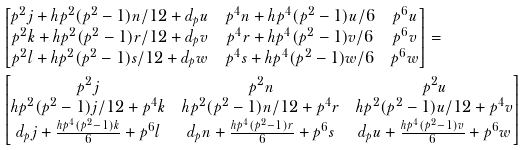Convert formula to latex. <formula><loc_0><loc_0><loc_500><loc_500>& \begin{bmatrix} p ^ { 2 } j + h p ^ { 2 } ( p ^ { 2 } - 1 ) n / 1 2 + d _ { p } u & p ^ { 4 } n + h p ^ { 4 } ( p ^ { 2 } - 1 ) u / 6 & p ^ { 6 } u \\ p ^ { 2 } k + h p ^ { 2 } ( p ^ { 2 } - 1 ) r / 1 2 + d _ { p } v & p ^ { 4 } r + h p ^ { 4 } ( p ^ { 2 } - 1 ) v / 6 & p ^ { 6 } v \\ p ^ { 2 } l + h p ^ { 2 } ( p ^ { 2 } - 1 ) s / 1 2 + d _ { p } w & p ^ { 4 } s + h p ^ { 4 } ( p ^ { 2 } - 1 ) w / 6 & p ^ { 6 } w \\ \end{bmatrix} = \\ & \begin{bmatrix} p ^ { 2 } j & p ^ { 2 } n & p ^ { 2 } u \\ h p ^ { 2 } ( p ^ { 2 } - 1 ) j / 1 2 + p ^ { 4 } k & h p ^ { 2 } ( p ^ { 2 } - 1 ) n / 1 2 + p ^ { 4 } r & h p ^ { 2 } ( p ^ { 2 } - 1 ) u / 1 2 + p ^ { 4 } v \\ d _ { p } j + \frac { h p ^ { 4 } ( p ^ { 2 } - 1 ) k } { 6 } + p ^ { 6 } l & d _ { p } n + \frac { h p ^ { 4 } ( p ^ { 2 } - 1 ) r } { 6 } + p ^ { 6 } s & d _ { p } u + \frac { h p ^ { 4 } ( p ^ { 2 } - 1 ) v } { 6 } + p ^ { 6 } w \end{bmatrix}</formula> 